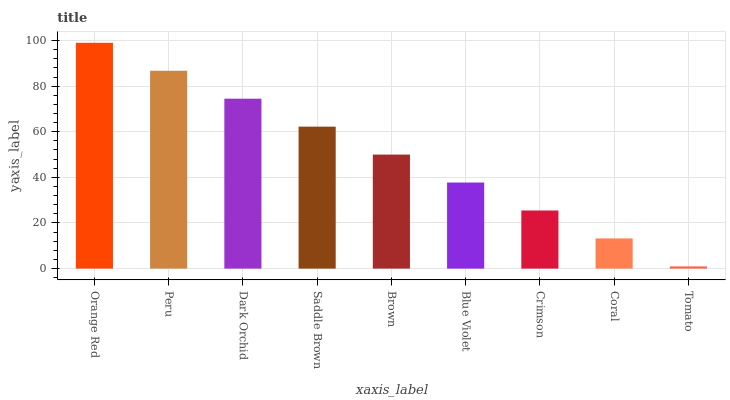Is Tomato the minimum?
Answer yes or no. Yes. Is Orange Red the maximum?
Answer yes or no. Yes. Is Peru the minimum?
Answer yes or no. No. Is Peru the maximum?
Answer yes or no. No. Is Orange Red greater than Peru?
Answer yes or no. Yes. Is Peru less than Orange Red?
Answer yes or no. Yes. Is Peru greater than Orange Red?
Answer yes or no. No. Is Orange Red less than Peru?
Answer yes or no. No. Is Brown the high median?
Answer yes or no. Yes. Is Brown the low median?
Answer yes or no. Yes. Is Dark Orchid the high median?
Answer yes or no. No. Is Tomato the low median?
Answer yes or no. No. 